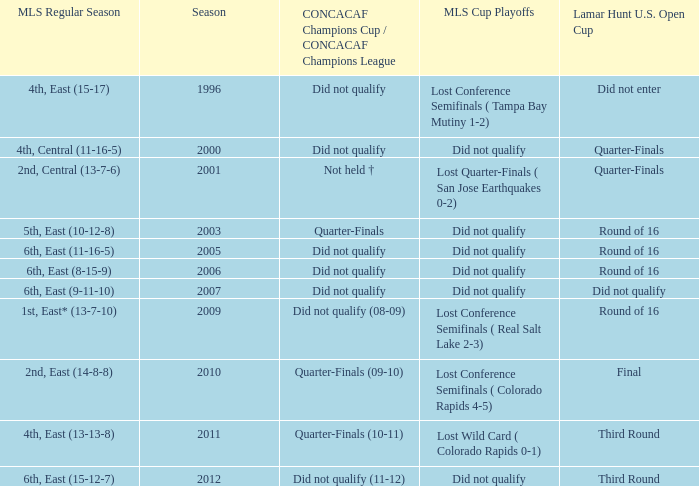How many mls cup playoffs where there for the mls regular season is 1st, east* (13-7-10)? 1.0. 